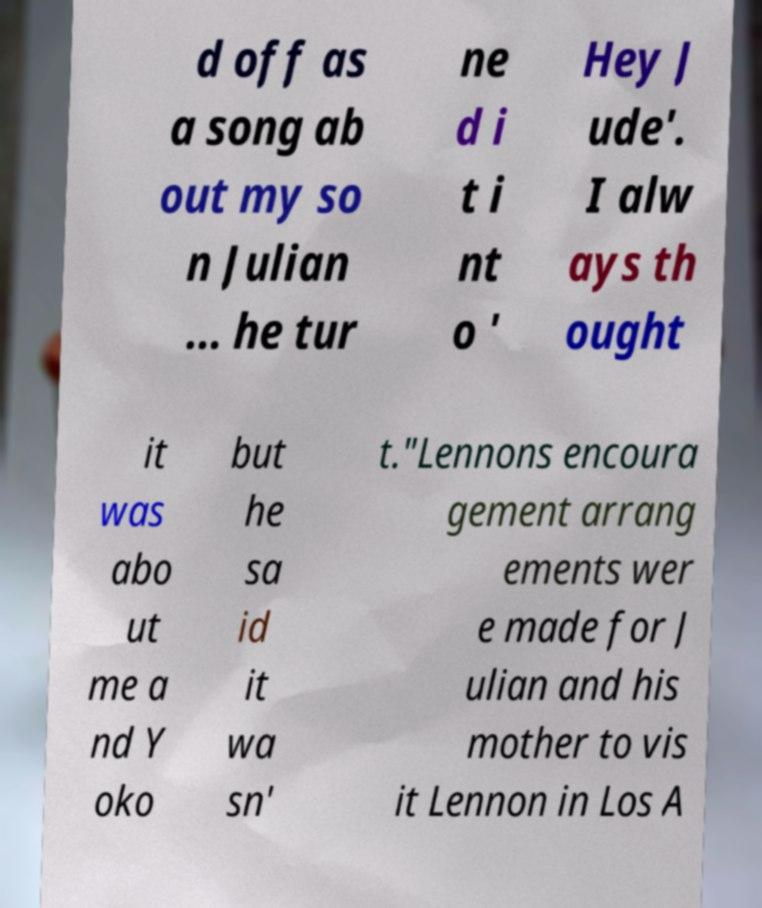Please read and relay the text visible in this image. What does it say? d off as a song ab out my so n Julian ... he tur ne d i t i nt o ' Hey J ude'. I alw ays th ought it was abo ut me a nd Y oko but he sa id it wa sn' t."Lennons encoura gement arrang ements wer e made for J ulian and his mother to vis it Lennon in Los A 